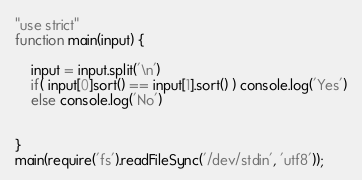<code> <loc_0><loc_0><loc_500><loc_500><_JavaScript_>"use strict"
function main(input) {

	input = input.split('\n')
	if( input[0]sort() == input[1].sort() ) console.log('Yes')
	else console.log('No')


}
main(require('fs').readFileSync('/dev/stdin', 'utf8'));</code> 